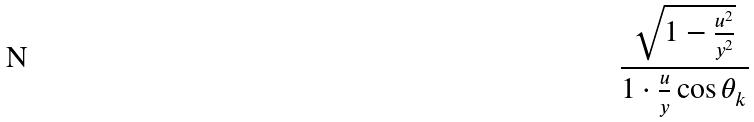<formula> <loc_0><loc_0><loc_500><loc_500>\frac { \sqrt { 1 - \frac { u ^ { 2 } } { y ^ { 2 } } } } { 1 \cdot \frac { u } { y } \cos \theta _ { k } }</formula> 